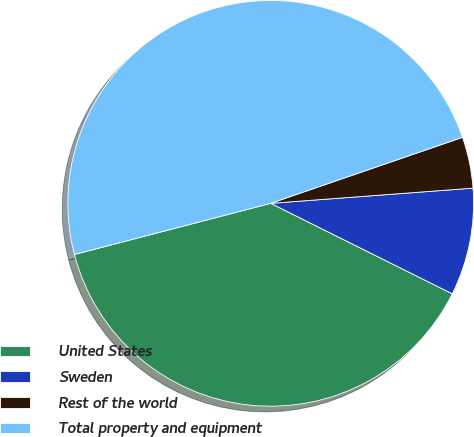Convert chart to OTSL. <chart><loc_0><loc_0><loc_500><loc_500><pie_chart><fcel>United States<fcel>Sweden<fcel>Rest of the world<fcel>Total property and equipment<nl><fcel>38.58%<fcel>8.55%<fcel>4.08%<fcel>48.78%<nl></chart> 